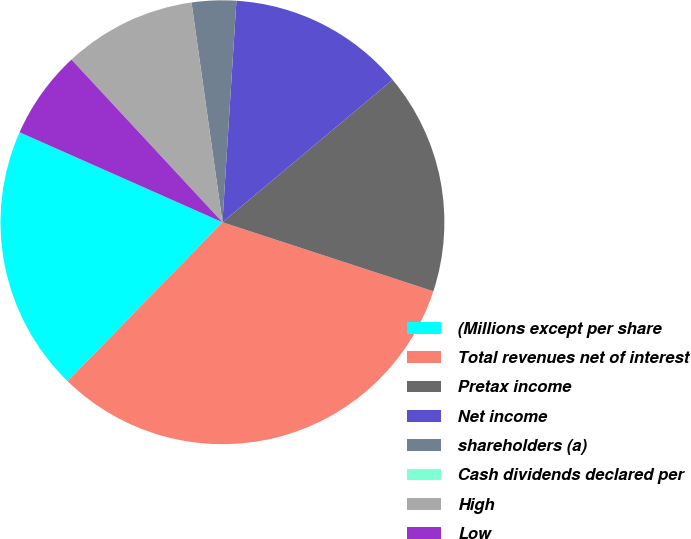Convert chart. <chart><loc_0><loc_0><loc_500><loc_500><pie_chart><fcel>(Millions except per share<fcel>Total revenues net of interest<fcel>Pretax income<fcel>Net income<fcel>shareholders (a)<fcel>Cash dividends declared per<fcel>High<fcel>Low<nl><fcel>19.35%<fcel>32.26%<fcel>16.13%<fcel>12.9%<fcel>3.23%<fcel>0.0%<fcel>9.68%<fcel>6.45%<nl></chart> 